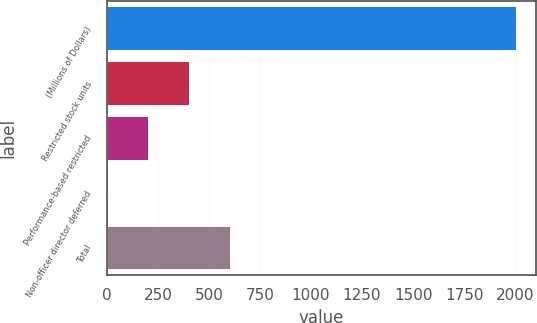Convert chart. <chart><loc_0><loc_0><loc_500><loc_500><bar_chart><fcel>(Millions of Dollars)<fcel>Restricted stock units<fcel>Performance-based restricted<fcel>Non-officer director deferred<fcel>Total<nl><fcel>2004<fcel>401.6<fcel>201.3<fcel>1<fcel>601.9<nl></chart> 